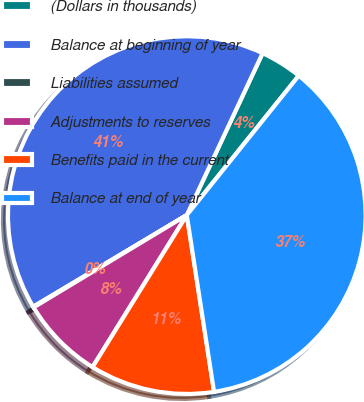Convert chart. <chart><loc_0><loc_0><loc_500><loc_500><pie_chart><fcel>(Dollars in thousands)<fcel>Balance at beginning of year<fcel>Liabilities assumed<fcel>Adjustments to reserves<fcel>Benefits paid in the current<fcel>Balance at end of year<nl><fcel>3.8%<fcel>40.53%<fcel>0.07%<fcel>7.54%<fcel>11.27%<fcel>36.8%<nl></chart> 